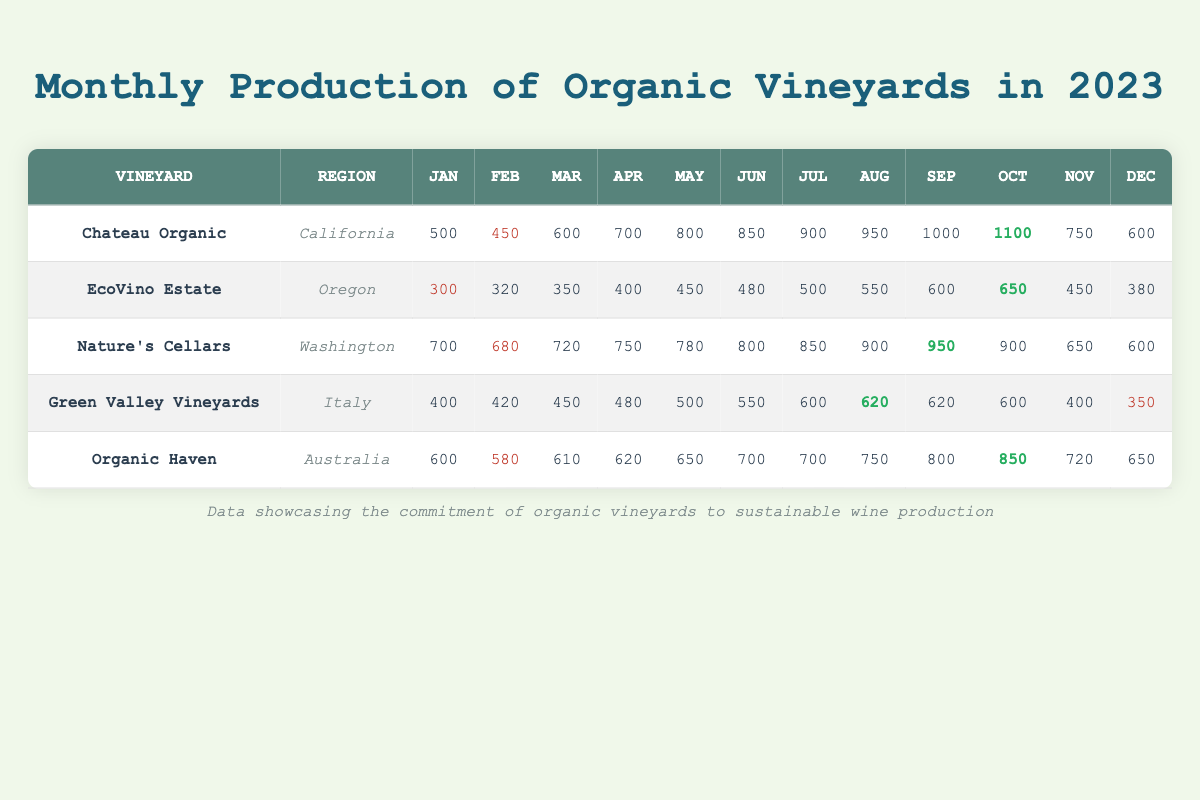What is the highest monthly production recorded by Chateau Organic? Looking at the table, Chateau Organic's highest production is in October, where it produced 1100 units.
Answer: 1100 Which vineyard had the lowest production in January? In January, EcoVino Estate produced the least with 300 units compared to the other vineyards.
Answer: 300 What is the total production of Nature's Cellars for the first half of the year (January to June)? By summing up Nature's Cellars' production from January to June: 700 + 680 + 720 + 750 + 780 + 800 = 3930.
Answer: 3930 Did Green Valley Vineyards have any month with production above 600 units? Yes, in July and August, Green Valley Vineyards produced 600 and 620 units respectively, which are above 600.
Answer: Yes What is the average monthly production for Organic Haven in 2023? To find the average, sum Organic Haven's monthly productions: 600 + 580 + 610 + 620 + 650 + 700 + 700 + 750 + 800 + 850 + 720 + 650 = 8200, and divide by the number of months (12). Thus, 8200 / 12 = 683.33.
Answer: 683.33 How many months did EcoVino Estate have a production below 400 units? Looking at EcoVino Estate's production, it had three months below 400: January (300), February (320), and March (350).
Answer: 3 Which vineyard consistently had the highest monthly production from June to October? By checking the productions from June to October, Chateau Organic consistently had the highest production in those months compared to the others.
Answer: Chateau Organic What was the total production for Green Valley Vineyards for the second half of the year? To find the total production from July to December for Green Valley Vineyards, sum: 600 + 620 + 620 + 600 + 400 + 350 = 2910.
Answer: 2910 Did any vineyard show an increase in production every month throughout the year? No vineyard showed a consistent monthly increase; all vineyards had some months where production decreased.
Answer: No What was the difference in production between the highest and lowest production month for Nature's Cellars? The highest production month was September (950 units) and the lowest was February (680 units). The difference is 950 - 680 = 270.
Answer: 270 Which vineyard had the greatest decline in production from one month to the next throughout the year? Upon examining the data, Green Valley Vineyards had a production drop from October (600) to November (400), which is a decline of 200 units, the greatest observed in a single transition.
Answer: 200 